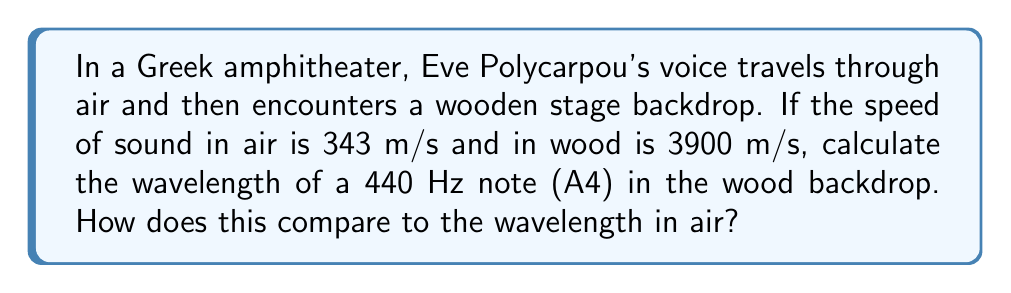What is the answer to this math problem? Let's approach this step-by-step:

1) First, recall the wave equation:
   $$ v = f\lambda $$
   where $v$ is the wave speed, $f$ is the frequency, and $\lambda$ is the wavelength.

2) For the air:
   $$ 343 = 440\lambda_{air} $$
   Solving for $\lambda_{air}$:
   $$ \lambda_{air} = \frac{343}{440} \approx 0.78 \text{ m} $$

3) For the wood:
   We use the same frequency (440 Hz) but a different speed (3900 m/s):
   $$ 3900 = 440\lambda_{wood} $$
   Solving for $\lambda_{wood}$:
   $$ \lambda_{wood} = \frac{3900}{440} \approx 8.86 \text{ m} $$

4) To compare, we can divide $\lambda_{wood}$ by $\lambda_{air}$:
   $$ \frac{\lambda_{wood}}{\lambda_{air}} = \frac{8.86}{0.78} \approx 11.36 $$

Thus, the wavelength in wood is about 11.36 times longer than in air.
Answer: $\lambda_{wood} \approx 8.86 \text{ m}$, which is 11.36 times longer than in air. 